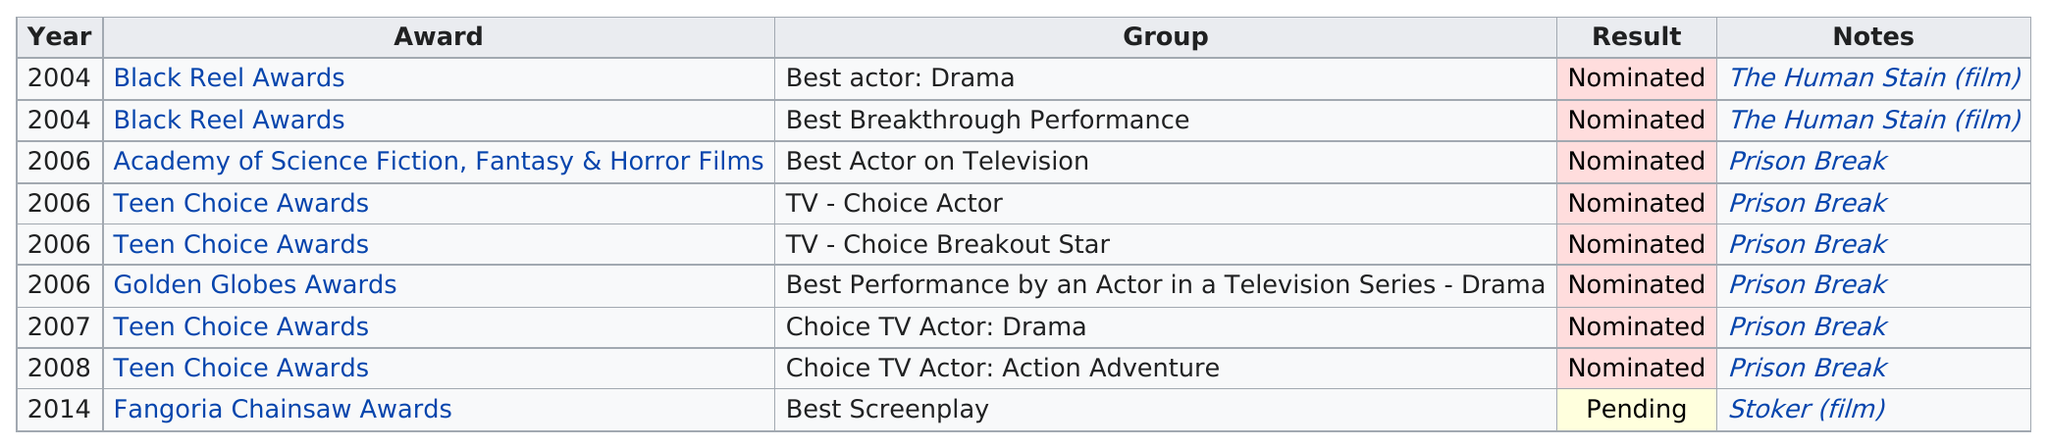Identify some key points in this picture. The first award he was nominated for was the Black Reel Awards. He has been nominated most for the Teen Choice Awards. His longest gap between awards nominations is 6 years. Wentworth Miller has been nominated for the most Teen Choice Awards. He has been nominated for four Teen Choice Awards. 